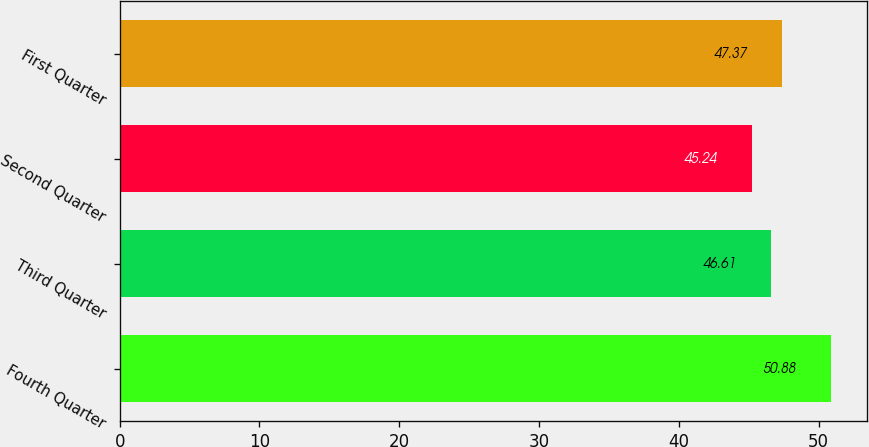Convert chart. <chart><loc_0><loc_0><loc_500><loc_500><bar_chart><fcel>Fourth Quarter<fcel>Third Quarter<fcel>Second Quarter<fcel>First Quarter<nl><fcel>50.88<fcel>46.61<fcel>45.24<fcel>47.37<nl></chart> 